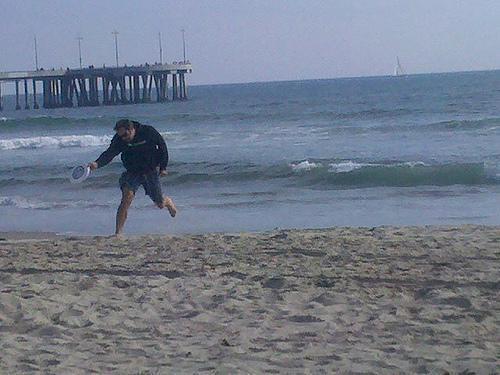How many people are in the photo?
Give a very brief answer. 1. 